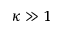Convert formula to latex. <formula><loc_0><loc_0><loc_500><loc_500>\kappa \gg 1</formula> 